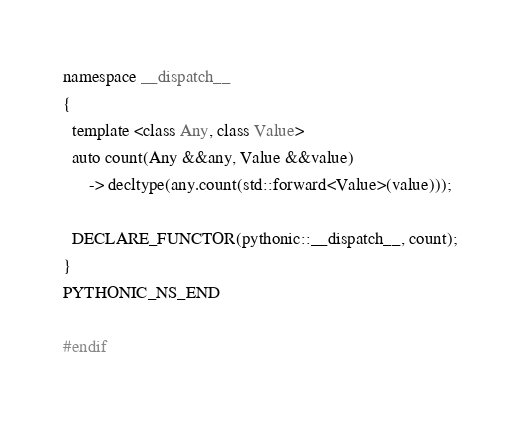<code> <loc_0><loc_0><loc_500><loc_500><_C++_>
namespace __dispatch__
{
  template <class Any, class Value>
  auto count(Any &&any, Value &&value)
      -> decltype(any.count(std::forward<Value>(value)));

  DECLARE_FUNCTOR(pythonic::__dispatch__, count);
}
PYTHONIC_NS_END

#endif
</code> 